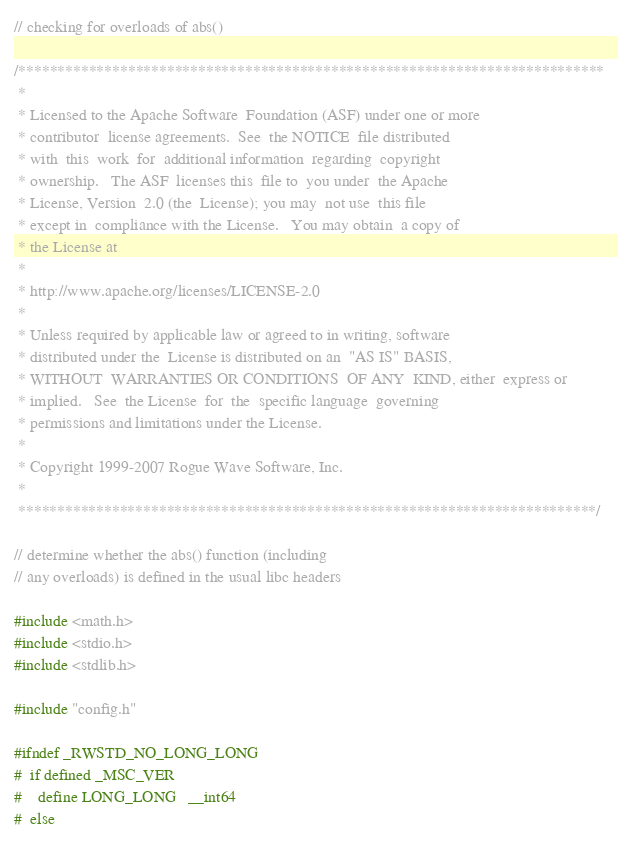<code> <loc_0><loc_0><loc_500><loc_500><_C++_>// checking for overloads of abs()

/***************************************************************************
 *
 * Licensed to the Apache Software  Foundation (ASF) under one or more
 * contributor  license agreements.  See  the NOTICE  file distributed
 * with  this  work  for  additional information  regarding  copyright
 * ownership.   The ASF  licenses this  file to  you under  the Apache
 * License, Version  2.0 (the  License); you may  not use  this file
 * except in  compliance with the License.   You may obtain  a copy of
 * the License at
 *
 * http://www.apache.org/licenses/LICENSE-2.0
 *
 * Unless required by applicable law or agreed to in writing, software
 * distributed under the  License is distributed on an  "AS IS" BASIS,
 * WITHOUT  WARRANTIES OR CONDITIONS  OF ANY  KIND, either  express or
 * implied.   See  the License  for  the  specific language  governing
 * permissions and limitations under the License.
 *
 * Copyright 1999-2007 Rogue Wave Software, Inc.
 * 
 **************************************************************************/

// determine whether the abs() function (including
// any overloads) is defined in the usual libc headers

#include <math.h>
#include <stdio.h>
#include <stdlib.h>

#include "config.h"

#ifndef _RWSTD_NO_LONG_LONG
#  if defined _MSC_VER
#    define LONG_LONG   __int64
#  else</code> 